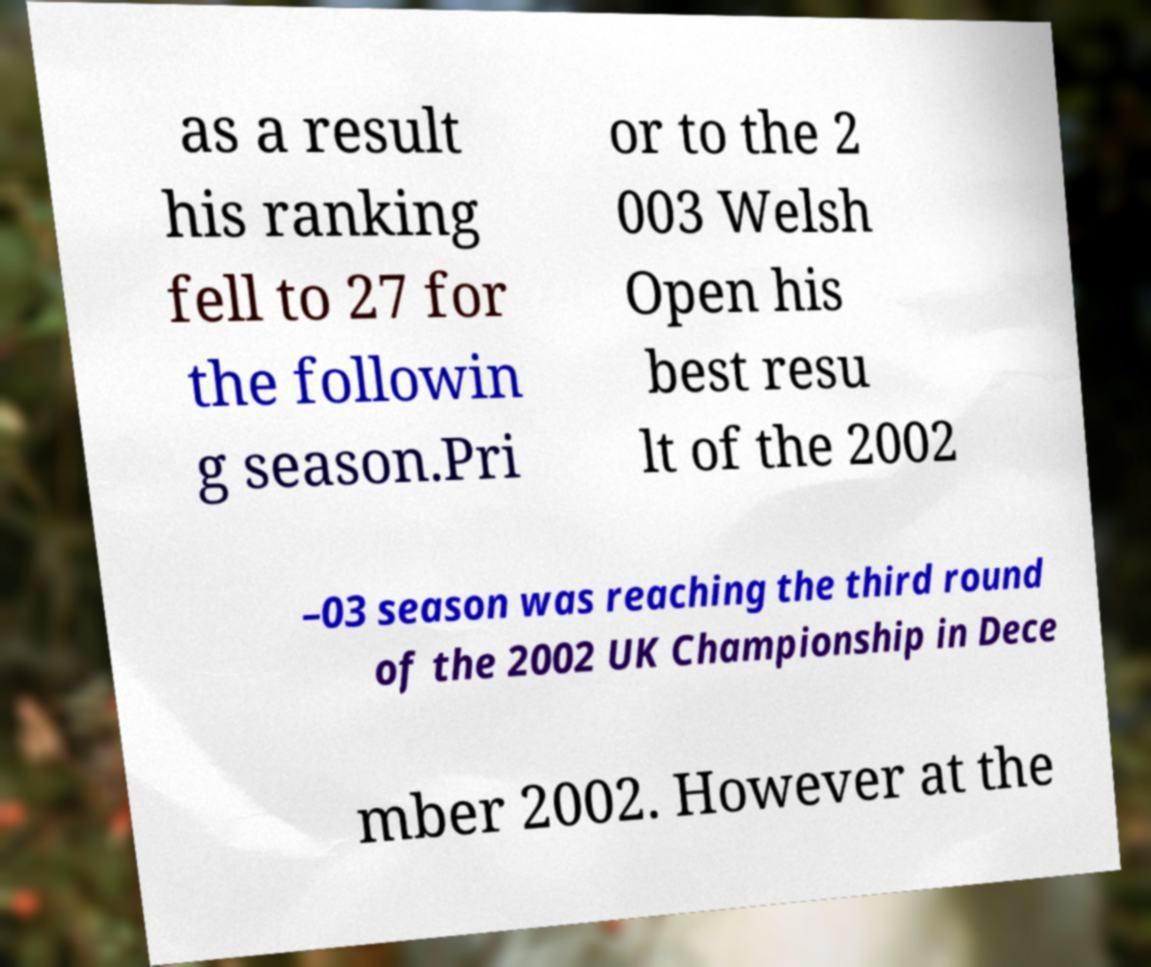I need the written content from this picture converted into text. Can you do that? as a result his ranking fell to 27 for the followin g season.Pri or to the 2 003 Welsh Open his best resu lt of the 2002 –03 season was reaching the third round of the 2002 UK Championship in Dece mber 2002. However at the 